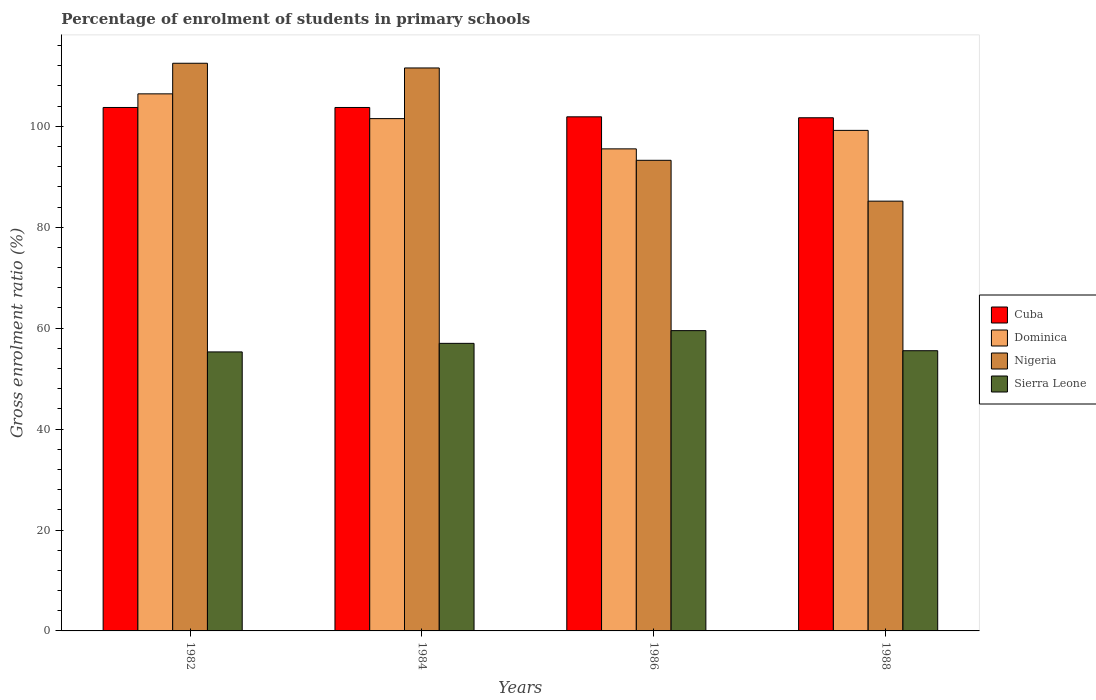Are the number of bars on each tick of the X-axis equal?
Make the answer very short. Yes. In how many cases, is the number of bars for a given year not equal to the number of legend labels?
Your answer should be very brief. 0. What is the percentage of students enrolled in primary schools in Dominica in 1984?
Offer a very short reply. 101.53. Across all years, what is the maximum percentage of students enrolled in primary schools in Sierra Leone?
Provide a succinct answer. 59.51. Across all years, what is the minimum percentage of students enrolled in primary schools in Dominica?
Provide a short and direct response. 95.53. In which year was the percentage of students enrolled in primary schools in Sierra Leone minimum?
Offer a very short reply. 1982. What is the total percentage of students enrolled in primary schools in Nigeria in the graph?
Give a very brief answer. 402.5. What is the difference between the percentage of students enrolled in primary schools in Nigeria in 1986 and that in 1988?
Provide a succinct answer. 8.1. What is the difference between the percentage of students enrolled in primary schools in Nigeria in 1982 and the percentage of students enrolled in primary schools in Dominica in 1984?
Provide a short and direct response. 10.97. What is the average percentage of students enrolled in primary schools in Cuba per year?
Offer a terse response. 102.76. In the year 1986, what is the difference between the percentage of students enrolled in primary schools in Cuba and percentage of students enrolled in primary schools in Dominica?
Provide a short and direct response. 6.35. What is the ratio of the percentage of students enrolled in primary schools in Cuba in 1986 to that in 1988?
Provide a succinct answer. 1. Is the difference between the percentage of students enrolled in primary schools in Cuba in 1982 and 1984 greater than the difference between the percentage of students enrolled in primary schools in Dominica in 1982 and 1984?
Your answer should be compact. No. What is the difference between the highest and the second highest percentage of students enrolled in primary schools in Nigeria?
Ensure brevity in your answer.  0.93. What is the difference between the highest and the lowest percentage of students enrolled in primary schools in Nigeria?
Your response must be concise. 27.33. In how many years, is the percentage of students enrolled in primary schools in Dominica greater than the average percentage of students enrolled in primary schools in Dominica taken over all years?
Ensure brevity in your answer.  2. Is the sum of the percentage of students enrolled in primary schools in Nigeria in 1984 and 1986 greater than the maximum percentage of students enrolled in primary schools in Cuba across all years?
Make the answer very short. Yes. Is it the case that in every year, the sum of the percentage of students enrolled in primary schools in Dominica and percentage of students enrolled in primary schools in Cuba is greater than the sum of percentage of students enrolled in primary schools in Nigeria and percentage of students enrolled in primary schools in Sierra Leone?
Ensure brevity in your answer.  No. What does the 4th bar from the left in 1982 represents?
Keep it short and to the point. Sierra Leone. What does the 2nd bar from the right in 1986 represents?
Offer a terse response. Nigeria. How many bars are there?
Offer a terse response. 16. Are all the bars in the graph horizontal?
Keep it short and to the point. No. What is the difference between two consecutive major ticks on the Y-axis?
Provide a succinct answer. 20. Are the values on the major ticks of Y-axis written in scientific E-notation?
Offer a very short reply. No. Does the graph contain any zero values?
Make the answer very short. No. Does the graph contain grids?
Make the answer very short. No. How many legend labels are there?
Your response must be concise. 4. How are the legend labels stacked?
Your answer should be very brief. Vertical. What is the title of the graph?
Offer a terse response. Percentage of enrolment of students in primary schools. Does "South Asia" appear as one of the legend labels in the graph?
Provide a succinct answer. No. What is the label or title of the X-axis?
Offer a very short reply. Years. What is the label or title of the Y-axis?
Offer a terse response. Gross enrolment ratio (%). What is the Gross enrolment ratio (%) in Cuba in 1982?
Your answer should be compact. 103.74. What is the Gross enrolment ratio (%) of Dominica in 1982?
Your answer should be compact. 106.44. What is the Gross enrolment ratio (%) of Nigeria in 1982?
Offer a terse response. 112.5. What is the Gross enrolment ratio (%) of Sierra Leone in 1982?
Offer a very short reply. 55.29. What is the Gross enrolment ratio (%) of Cuba in 1984?
Ensure brevity in your answer.  103.74. What is the Gross enrolment ratio (%) in Dominica in 1984?
Keep it short and to the point. 101.53. What is the Gross enrolment ratio (%) in Nigeria in 1984?
Ensure brevity in your answer.  111.57. What is the Gross enrolment ratio (%) of Sierra Leone in 1984?
Offer a very short reply. 56.99. What is the Gross enrolment ratio (%) of Cuba in 1986?
Your answer should be very brief. 101.88. What is the Gross enrolment ratio (%) of Dominica in 1986?
Make the answer very short. 95.53. What is the Gross enrolment ratio (%) in Nigeria in 1986?
Make the answer very short. 93.27. What is the Gross enrolment ratio (%) in Sierra Leone in 1986?
Offer a terse response. 59.51. What is the Gross enrolment ratio (%) of Cuba in 1988?
Your answer should be very brief. 101.7. What is the Gross enrolment ratio (%) in Dominica in 1988?
Keep it short and to the point. 99.2. What is the Gross enrolment ratio (%) of Nigeria in 1988?
Your answer should be very brief. 85.17. What is the Gross enrolment ratio (%) in Sierra Leone in 1988?
Provide a short and direct response. 55.53. Across all years, what is the maximum Gross enrolment ratio (%) of Cuba?
Give a very brief answer. 103.74. Across all years, what is the maximum Gross enrolment ratio (%) in Dominica?
Offer a terse response. 106.44. Across all years, what is the maximum Gross enrolment ratio (%) of Nigeria?
Provide a succinct answer. 112.5. Across all years, what is the maximum Gross enrolment ratio (%) of Sierra Leone?
Ensure brevity in your answer.  59.51. Across all years, what is the minimum Gross enrolment ratio (%) in Cuba?
Offer a terse response. 101.7. Across all years, what is the minimum Gross enrolment ratio (%) of Dominica?
Your response must be concise. 95.53. Across all years, what is the minimum Gross enrolment ratio (%) of Nigeria?
Offer a terse response. 85.17. Across all years, what is the minimum Gross enrolment ratio (%) of Sierra Leone?
Keep it short and to the point. 55.29. What is the total Gross enrolment ratio (%) of Cuba in the graph?
Make the answer very short. 411.05. What is the total Gross enrolment ratio (%) in Dominica in the graph?
Keep it short and to the point. 402.69. What is the total Gross enrolment ratio (%) in Nigeria in the graph?
Your answer should be very brief. 402.5. What is the total Gross enrolment ratio (%) in Sierra Leone in the graph?
Provide a succinct answer. 227.32. What is the difference between the Gross enrolment ratio (%) of Cuba in 1982 and that in 1984?
Keep it short and to the point. 0. What is the difference between the Gross enrolment ratio (%) of Dominica in 1982 and that in 1984?
Keep it short and to the point. 4.91. What is the difference between the Gross enrolment ratio (%) in Nigeria in 1982 and that in 1984?
Provide a short and direct response. 0.93. What is the difference between the Gross enrolment ratio (%) in Sierra Leone in 1982 and that in 1984?
Keep it short and to the point. -1.7. What is the difference between the Gross enrolment ratio (%) of Cuba in 1982 and that in 1986?
Your answer should be very brief. 1.85. What is the difference between the Gross enrolment ratio (%) in Dominica in 1982 and that in 1986?
Keep it short and to the point. 10.9. What is the difference between the Gross enrolment ratio (%) in Nigeria in 1982 and that in 1986?
Offer a terse response. 19.23. What is the difference between the Gross enrolment ratio (%) of Sierra Leone in 1982 and that in 1986?
Offer a terse response. -4.22. What is the difference between the Gross enrolment ratio (%) of Cuba in 1982 and that in 1988?
Make the answer very short. 2.04. What is the difference between the Gross enrolment ratio (%) of Dominica in 1982 and that in 1988?
Offer a very short reply. 7.24. What is the difference between the Gross enrolment ratio (%) in Nigeria in 1982 and that in 1988?
Provide a succinct answer. 27.33. What is the difference between the Gross enrolment ratio (%) of Sierra Leone in 1982 and that in 1988?
Ensure brevity in your answer.  -0.24. What is the difference between the Gross enrolment ratio (%) in Cuba in 1984 and that in 1986?
Offer a very short reply. 1.85. What is the difference between the Gross enrolment ratio (%) of Dominica in 1984 and that in 1986?
Provide a short and direct response. 6. What is the difference between the Gross enrolment ratio (%) in Nigeria in 1984 and that in 1986?
Make the answer very short. 18.3. What is the difference between the Gross enrolment ratio (%) of Sierra Leone in 1984 and that in 1986?
Give a very brief answer. -2.52. What is the difference between the Gross enrolment ratio (%) of Cuba in 1984 and that in 1988?
Make the answer very short. 2.04. What is the difference between the Gross enrolment ratio (%) of Dominica in 1984 and that in 1988?
Provide a short and direct response. 2.33. What is the difference between the Gross enrolment ratio (%) in Nigeria in 1984 and that in 1988?
Your response must be concise. 26.4. What is the difference between the Gross enrolment ratio (%) of Sierra Leone in 1984 and that in 1988?
Your response must be concise. 1.46. What is the difference between the Gross enrolment ratio (%) of Cuba in 1986 and that in 1988?
Your answer should be compact. 0.19. What is the difference between the Gross enrolment ratio (%) of Dominica in 1986 and that in 1988?
Your answer should be compact. -3.66. What is the difference between the Gross enrolment ratio (%) in Nigeria in 1986 and that in 1988?
Provide a succinct answer. 8.1. What is the difference between the Gross enrolment ratio (%) in Sierra Leone in 1986 and that in 1988?
Your response must be concise. 3.98. What is the difference between the Gross enrolment ratio (%) of Cuba in 1982 and the Gross enrolment ratio (%) of Dominica in 1984?
Offer a terse response. 2.21. What is the difference between the Gross enrolment ratio (%) in Cuba in 1982 and the Gross enrolment ratio (%) in Nigeria in 1984?
Provide a short and direct response. -7.83. What is the difference between the Gross enrolment ratio (%) in Cuba in 1982 and the Gross enrolment ratio (%) in Sierra Leone in 1984?
Your answer should be compact. 46.75. What is the difference between the Gross enrolment ratio (%) of Dominica in 1982 and the Gross enrolment ratio (%) of Nigeria in 1984?
Make the answer very short. -5.13. What is the difference between the Gross enrolment ratio (%) in Dominica in 1982 and the Gross enrolment ratio (%) in Sierra Leone in 1984?
Offer a terse response. 49.45. What is the difference between the Gross enrolment ratio (%) of Nigeria in 1982 and the Gross enrolment ratio (%) of Sierra Leone in 1984?
Keep it short and to the point. 55.51. What is the difference between the Gross enrolment ratio (%) of Cuba in 1982 and the Gross enrolment ratio (%) of Dominica in 1986?
Offer a terse response. 8.2. What is the difference between the Gross enrolment ratio (%) of Cuba in 1982 and the Gross enrolment ratio (%) of Nigeria in 1986?
Your answer should be compact. 10.47. What is the difference between the Gross enrolment ratio (%) in Cuba in 1982 and the Gross enrolment ratio (%) in Sierra Leone in 1986?
Your response must be concise. 44.23. What is the difference between the Gross enrolment ratio (%) of Dominica in 1982 and the Gross enrolment ratio (%) of Nigeria in 1986?
Provide a succinct answer. 13.17. What is the difference between the Gross enrolment ratio (%) of Dominica in 1982 and the Gross enrolment ratio (%) of Sierra Leone in 1986?
Offer a terse response. 46.92. What is the difference between the Gross enrolment ratio (%) of Nigeria in 1982 and the Gross enrolment ratio (%) of Sierra Leone in 1986?
Your answer should be very brief. 52.99. What is the difference between the Gross enrolment ratio (%) of Cuba in 1982 and the Gross enrolment ratio (%) of Dominica in 1988?
Keep it short and to the point. 4.54. What is the difference between the Gross enrolment ratio (%) in Cuba in 1982 and the Gross enrolment ratio (%) in Nigeria in 1988?
Your answer should be compact. 18.57. What is the difference between the Gross enrolment ratio (%) in Cuba in 1982 and the Gross enrolment ratio (%) in Sierra Leone in 1988?
Ensure brevity in your answer.  48.21. What is the difference between the Gross enrolment ratio (%) of Dominica in 1982 and the Gross enrolment ratio (%) of Nigeria in 1988?
Your answer should be very brief. 21.26. What is the difference between the Gross enrolment ratio (%) in Dominica in 1982 and the Gross enrolment ratio (%) in Sierra Leone in 1988?
Offer a terse response. 50.9. What is the difference between the Gross enrolment ratio (%) of Nigeria in 1982 and the Gross enrolment ratio (%) of Sierra Leone in 1988?
Offer a terse response. 56.97. What is the difference between the Gross enrolment ratio (%) in Cuba in 1984 and the Gross enrolment ratio (%) in Dominica in 1986?
Keep it short and to the point. 8.2. What is the difference between the Gross enrolment ratio (%) of Cuba in 1984 and the Gross enrolment ratio (%) of Nigeria in 1986?
Keep it short and to the point. 10.47. What is the difference between the Gross enrolment ratio (%) in Cuba in 1984 and the Gross enrolment ratio (%) in Sierra Leone in 1986?
Offer a terse response. 44.22. What is the difference between the Gross enrolment ratio (%) in Dominica in 1984 and the Gross enrolment ratio (%) in Nigeria in 1986?
Your response must be concise. 8.26. What is the difference between the Gross enrolment ratio (%) in Dominica in 1984 and the Gross enrolment ratio (%) in Sierra Leone in 1986?
Make the answer very short. 42.02. What is the difference between the Gross enrolment ratio (%) in Nigeria in 1984 and the Gross enrolment ratio (%) in Sierra Leone in 1986?
Provide a short and direct response. 52.05. What is the difference between the Gross enrolment ratio (%) of Cuba in 1984 and the Gross enrolment ratio (%) of Dominica in 1988?
Provide a succinct answer. 4.54. What is the difference between the Gross enrolment ratio (%) in Cuba in 1984 and the Gross enrolment ratio (%) in Nigeria in 1988?
Your response must be concise. 18.57. What is the difference between the Gross enrolment ratio (%) in Cuba in 1984 and the Gross enrolment ratio (%) in Sierra Leone in 1988?
Offer a terse response. 48.21. What is the difference between the Gross enrolment ratio (%) in Dominica in 1984 and the Gross enrolment ratio (%) in Nigeria in 1988?
Your answer should be very brief. 16.36. What is the difference between the Gross enrolment ratio (%) in Dominica in 1984 and the Gross enrolment ratio (%) in Sierra Leone in 1988?
Offer a very short reply. 46. What is the difference between the Gross enrolment ratio (%) in Nigeria in 1984 and the Gross enrolment ratio (%) in Sierra Leone in 1988?
Keep it short and to the point. 56.04. What is the difference between the Gross enrolment ratio (%) in Cuba in 1986 and the Gross enrolment ratio (%) in Dominica in 1988?
Make the answer very short. 2.69. What is the difference between the Gross enrolment ratio (%) in Cuba in 1986 and the Gross enrolment ratio (%) in Nigeria in 1988?
Provide a succinct answer. 16.71. What is the difference between the Gross enrolment ratio (%) of Cuba in 1986 and the Gross enrolment ratio (%) of Sierra Leone in 1988?
Give a very brief answer. 46.35. What is the difference between the Gross enrolment ratio (%) of Dominica in 1986 and the Gross enrolment ratio (%) of Nigeria in 1988?
Give a very brief answer. 10.36. What is the difference between the Gross enrolment ratio (%) of Dominica in 1986 and the Gross enrolment ratio (%) of Sierra Leone in 1988?
Provide a short and direct response. 40. What is the difference between the Gross enrolment ratio (%) in Nigeria in 1986 and the Gross enrolment ratio (%) in Sierra Leone in 1988?
Ensure brevity in your answer.  37.74. What is the average Gross enrolment ratio (%) in Cuba per year?
Ensure brevity in your answer.  102.76. What is the average Gross enrolment ratio (%) in Dominica per year?
Your answer should be compact. 100.67. What is the average Gross enrolment ratio (%) of Nigeria per year?
Your response must be concise. 100.63. What is the average Gross enrolment ratio (%) of Sierra Leone per year?
Give a very brief answer. 56.83. In the year 1982, what is the difference between the Gross enrolment ratio (%) of Cuba and Gross enrolment ratio (%) of Dominica?
Make the answer very short. -2.7. In the year 1982, what is the difference between the Gross enrolment ratio (%) of Cuba and Gross enrolment ratio (%) of Nigeria?
Offer a terse response. -8.76. In the year 1982, what is the difference between the Gross enrolment ratio (%) of Cuba and Gross enrolment ratio (%) of Sierra Leone?
Your response must be concise. 48.44. In the year 1982, what is the difference between the Gross enrolment ratio (%) in Dominica and Gross enrolment ratio (%) in Nigeria?
Give a very brief answer. -6.06. In the year 1982, what is the difference between the Gross enrolment ratio (%) of Dominica and Gross enrolment ratio (%) of Sierra Leone?
Your response must be concise. 51.14. In the year 1982, what is the difference between the Gross enrolment ratio (%) in Nigeria and Gross enrolment ratio (%) in Sierra Leone?
Provide a short and direct response. 57.21. In the year 1984, what is the difference between the Gross enrolment ratio (%) of Cuba and Gross enrolment ratio (%) of Dominica?
Keep it short and to the point. 2.21. In the year 1984, what is the difference between the Gross enrolment ratio (%) in Cuba and Gross enrolment ratio (%) in Nigeria?
Provide a short and direct response. -7.83. In the year 1984, what is the difference between the Gross enrolment ratio (%) of Cuba and Gross enrolment ratio (%) of Sierra Leone?
Your response must be concise. 46.75. In the year 1984, what is the difference between the Gross enrolment ratio (%) of Dominica and Gross enrolment ratio (%) of Nigeria?
Your answer should be compact. -10.04. In the year 1984, what is the difference between the Gross enrolment ratio (%) of Dominica and Gross enrolment ratio (%) of Sierra Leone?
Ensure brevity in your answer.  44.54. In the year 1984, what is the difference between the Gross enrolment ratio (%) of Nigeria and Gross enrolment ratio (%) of Sierra Leone?
Your response must be concise. 54.58. In the year 1986, what is the difference between the Gross enrolment ratio (%) of Cuba and Gross enrolment ratio (%) of Dominica?
Keep it short and to the point. 6.35. In the year 1986, what is the difference between the Gross enrolment ratio (%) of Cuba and Gross enrolment ratio (%) of Nigeria?
Your answer should be very brief. 8.62. In the year 1986, what is the difference between the Gross enrolment ratio (%) of Cuba and Gross enrolment ratio (%) of Sierra Leone?
Give a very brief answer. 42.37. In the year 1986, what is the difference between the Gross enrolment ratio (%) in Dominica and Gross enrolment ratio (%) in Nigeria?
Give a very brief answer. 2.27. In the year 1986, what is the difference between the Gross enrolment ratio (%) in Dominica and Gross enrolment ratio (%) in Sierra Leone?
Provide a succinct answer. 36.02. In the year 1986, what is the difference between the Gross enrolment ratio (%) in Nigeria and Gross enrolment ratio (%) in Sierra Leone?
Give a very brief answer. 33.76. In the year 1988, what is the difference between the Gross enrolment ratio (%) in Cuba and Gross enrolment ratio (%) in Dominica?
Make the answer very short. 2.5. In the year 1988, what is the difference between the Gross enrolment ratio (%) of Cuba and Gross enrolment ratio (%) of Nigeria?
Ensure brevity in your answer.  16.53. In the year 1988, what is the difference between the Gross enrolment ratio (%) of Cuba and Gross enrolment ratio (%) of Sierra Leone?
Your response must be concise. 46.17. In the year 1988, what is the difference between the Gross enrolment ratio (%) in Dominica and Gross enrolment ratio (%) in Nigeria?
Your response must be concise. 14.03. In the year 1988, what is the difference between the Gross enrolment ratio (%) in Dominica and Gross enrolment ratio (%) in Sierra Leone?
Provide a succinct answer. 43.67. In the year 1988, what is the difference between the Gross enrolment ratio (%) of Nigeria and Gross enrolment ratio (%) of Sierra Leone?
Provide a short and direct response. 29.64. What is the ratio of the Gross enrolment ratio (%) of Dominica in 1982 to that in 1984?
Your answer should be very brief. 1.05. What is the ratio of the Gross enrolment ratio (%) in Nigeria in 1982 to that in 1984?
Make the answer very short. 1.01. What is the ratio of the Gross enrolment ratio (%) of Sierra Leone in 1982 to that in 1984?
Your answer should be compact. 0.97. What is the ratio of the Gross enrolment ratio (%) of Cuba in 1982 to that in 1986?
Your response must be concise. 1.02. What is the ratio of the Gross enrolment ratio (%) in Dominica in 1982 to that in 1986?
Your response must be concise. 1.11. What is the ratio of the Gross enrolment ratio (%) in Nigeria in 1982 to that in 1986?
Keep it short and to the point. 1.21. What is the ratio of the Gross enrolment ratio (%) in Sierra Leone in 1982 to that in 1986?
Provide a short and direct response. 0.93. What is the ratio of the Gross enrolment ratio (%) of Cuba in 1982 to that in 1988?
Offer a terse response. 1.02. What is the ratio of the Gross enrolment ratio (%) in Dominica in 1982 to that in 1988?
Keep it short and to the point. 1.07. What is the ratio of the Gross enrolment ratio (%) in Nigeria in 1982 to that in 1988?
Keep it short and to the point. 1.32. What is the ratio of the Gross enrolment ratio (%) in Sierra Leone in 1982 to that in 1988?
Your answer should be compact. 1. What is the ratio of the Gross enrolment ratio (%) of Cuba in 1984 to that in 1986?
Keep it short and to the point. 1.02. What is the ratio of the Gross enrolment ratio (%) in Dominica in 1984 to that in 1986?
Provide a succinct answer. 1.06. What is the ratio of the Gross enrolment ratio (%) in Nigeria in 1984 to that in 1986?
Ensure brevity in your answer.  1.2. What is the ratio of the Gross enrolment ratio (%) in Sierra Leone in 1984 to that in 1986?
Make the answer very short. 0.96. What is the ratio of the Gross enrolment ratio (%) in Dominica in 1984 to that in 1988?
Your response must be concise. 1.02. What is the ratio of the Gross enrolment ratio (%) of Nigeria in 1984 to that in 1988?
Ensure brevity in your answer.  1.31. What is the ratio of the Gross enrolment ratio (%) in Sierra Leone in 1984 to that in 1988?
Provide a short and direct response. 1.03. What is the ratio of the Gross enrolment ratio (%) of Dominica in 1986 to that in 1988?
Provide a succinct answer. 0.96. What is the ratio of the Gross enrolment ratio (%) in Nigeria in 1986 to that in 1988?
Ensure brevity in your answer.  1.1. What is the ratio of the Gross enrolment ratio (%) of Sierra Leone in 1986 to that in 1988?
Your response must be concise. 1.07. What is the difference between the highest and the second highest Gross enrolment ratio (%) of Cuba?
Offer a very short reply. 0. What is the difference between the highest and the second highest Gross enrolment ratio (%) of Dominica?
Offer a terse response. 4.91. What is the difference between the highest and the second highest Gross enrolment ratio (%) of Nigeria?
Your answer should be very brief. 0.93. What is the difference between the highest and the second highest Gross enrolment ratio (%) of Sierra Leone?
Keep it short and to the point. 2.52. What is the difference between the highest and the lowest Gross enrolment ratio (%) of Cuba?
Provide a succinct answer. 2.04. What is the difference between the highest and the lowest Gross enrolment ratio (%) of Dominica?
Your answer should be compact. 10.9. What is the difference between the highest and the lowest Gross enrolment ratio (%) of Nigeria?
Make the answer very short. 27.33. What is the difference between the highest and the lowest Gross enrolment ratio (%) of Sierra Leone?
Your response must be concise. 4.22. 